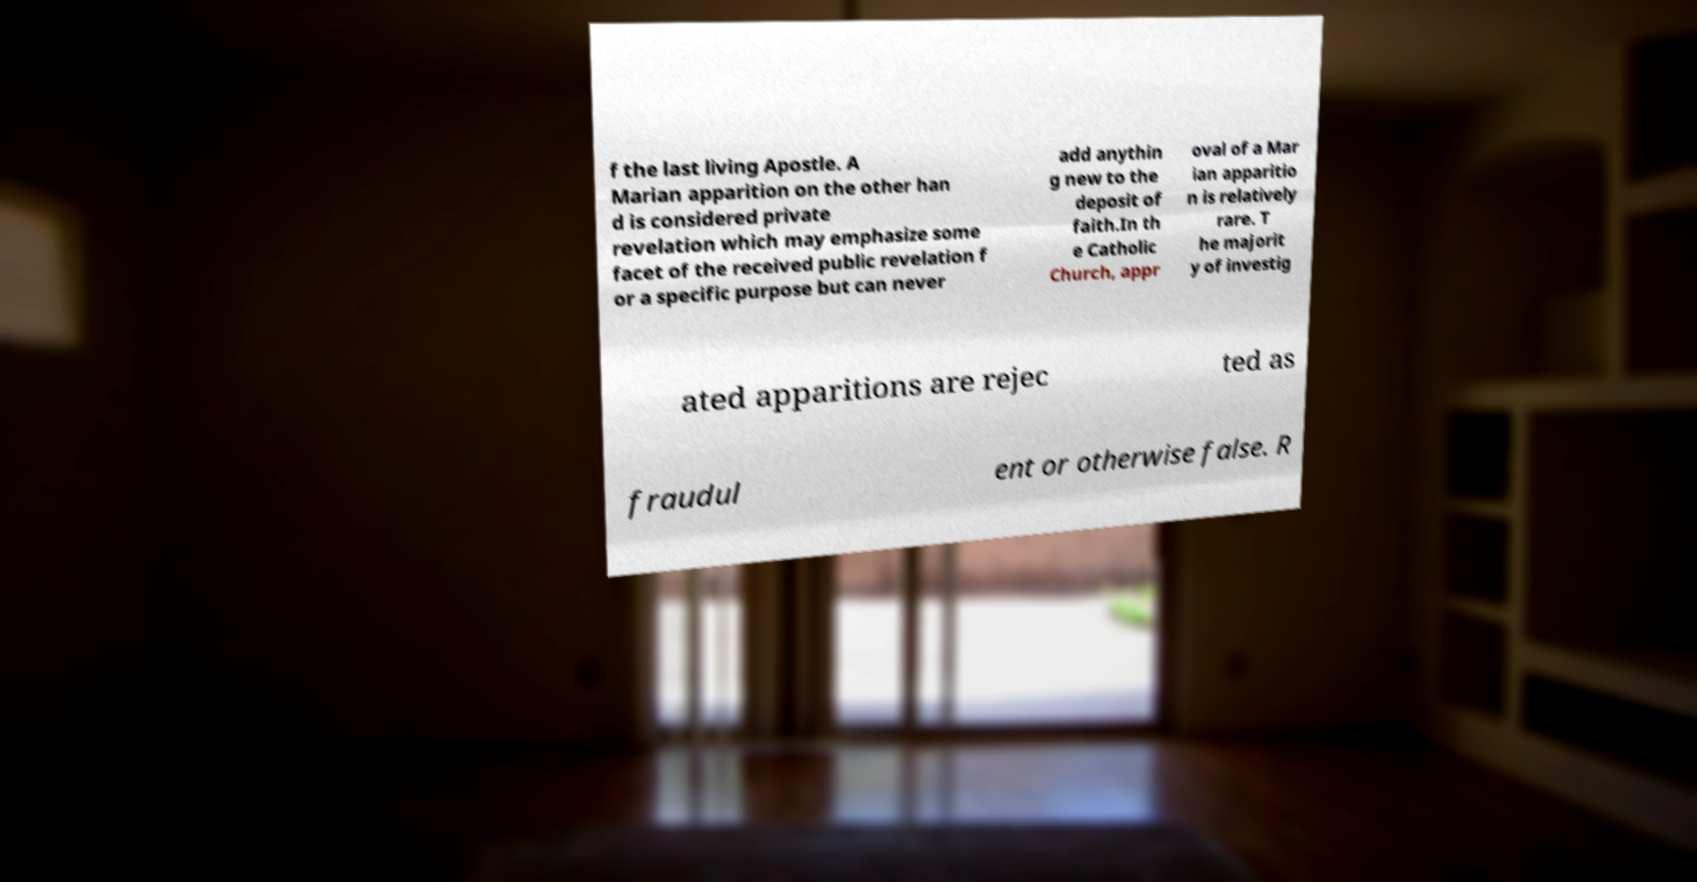I need the written content from this picture converted into text. Can you do that? f the last living Apostle. A Marian apparition on the other han d is considered private revelation which may emphasize some facet of the received public revelation f or a specific purpose but can never add anythin g new to the deposit of faith.In th e Catholic Church, appr oval of a Mar ian apparitio n is relatively rare. T he majorit y of investig ated apparitions are rejec ted as fraudul ent or otherwise false. R 